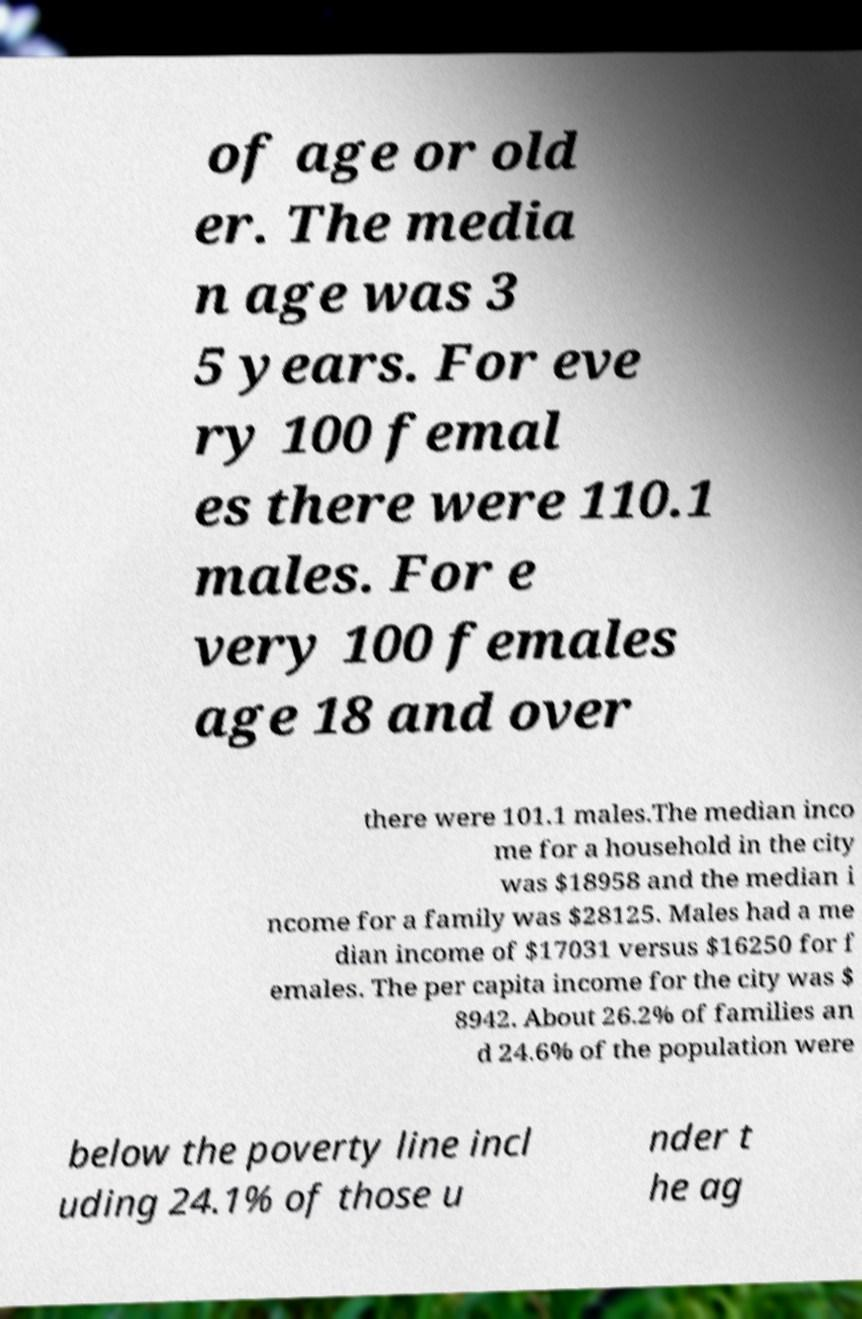What messages or text are displayed in this image? I need them in a readable, typed format. of age or old er. The media n age was 3 5 years. For eve ry 100 femal es there were 110.1 males. For e very 100 females age 18 and over there were 101.1 males.The median inco me for a household in the city was $18958 and the median i ncome for a family was $28125. Males had a me dian income of $17031 versus $16250 for f emales. The per capita income for the city was $ 8942. About 26.2% of families an d 24.6% of the population were below the poverty line incl uding 24.1% of those u nder t he ag 